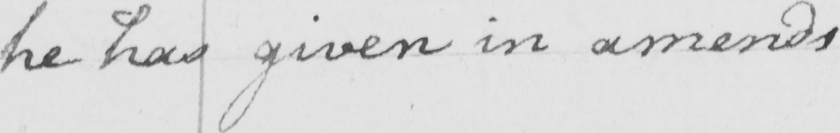What text is written in this handwritten line? he has given in amends 